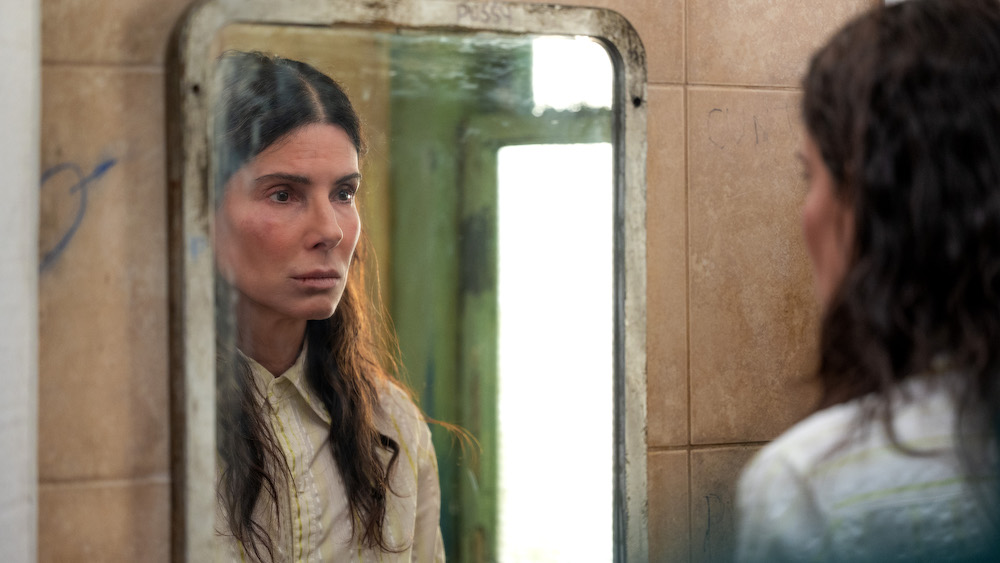Describe the following image. In this image, we see a woman, who appears to be standing in a dilapidated bathroom. She is gazing intently at her own reflection in a dirty, worn mirror. She is dressed in a simple beige jacket and her hair is neatly pulled back. The surroundings are grim, with graffiti scribbled on the walls, adding to an atmosphere of neglect and desolation. The diffuse light filtering through a window highlights the somber mood of the scene. 